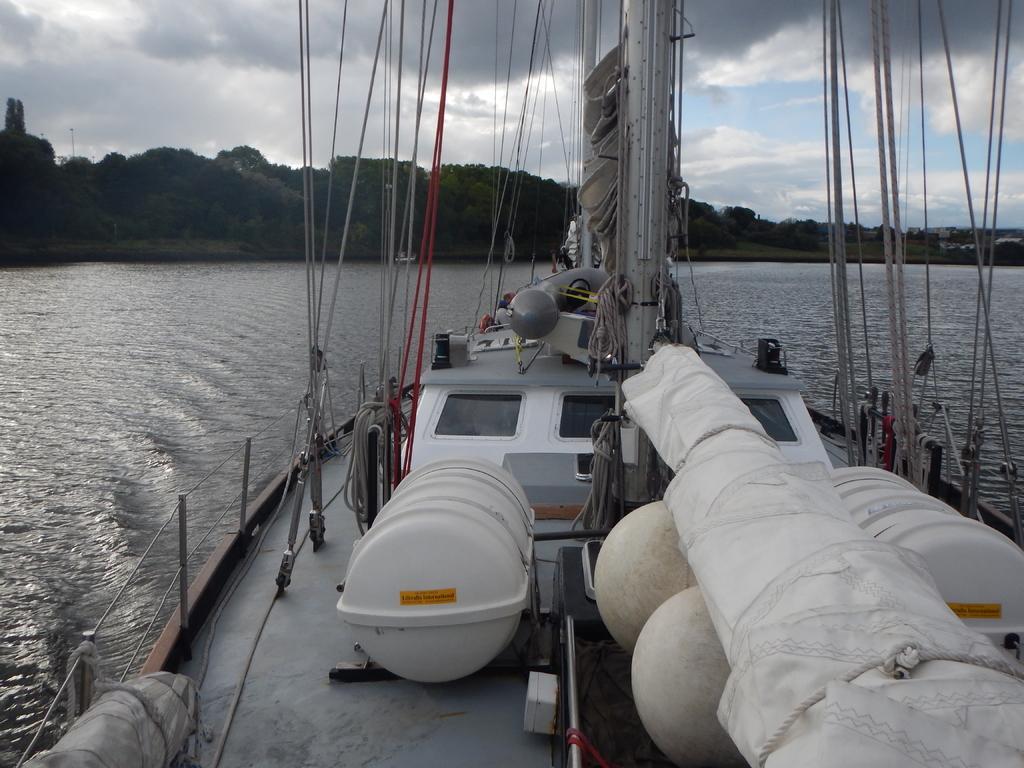Please provide a concise description of this image. In this image we can see a boat containing wires, pole, cloth tied with a rope, windows and a container on the water. On the backside we can see a group of trees and the sky which looks cloudy. 